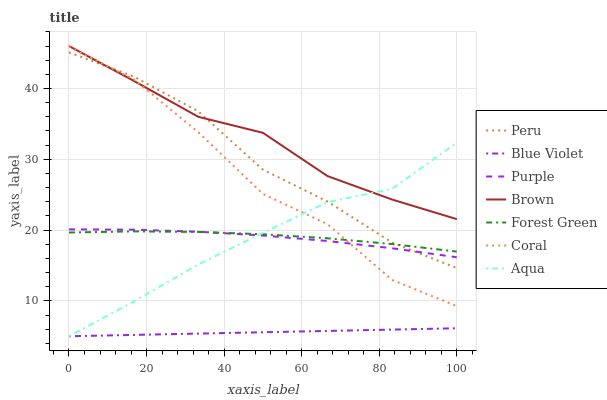Does Blue Violet have the minimum area under the curve?
Answer yes or no. Yes. Does Brown have the maximum area under the curve?
Answer yes or no. Yes. Does Purple have the minimum area under the curve?
Answer yes or no. No. Does Purple have the maximum area under the curve?
Answer yes or no. No. Is Blue Violet the smoothest?
Answer yes or no. Yes. Is Coral the roughest?
Answer yes or no. Yes. Is Purple the smoothest?
Answer yes or no. No. Is Purple the roughest?
Answer yes or no. No. Does Purple have the lowest value?
Answer yes or no. No. Does Brown have the highest value?
Answer yes or no. Yes. Does Purple have the highest value?
Answer yes or no. No. Is Blue Violet less than Coral?
Answer yes or no. Yes. Is Purple greater than Blue Violet?
Answer yes or no. Yes. Does Purple intersect Aqua?
Answer yes or no. Yes. Is Purple less than Aqua?
Answer yes or no. No. Is Purple greater than Aqua?
Answer yes or no. No. Does Blue Violet intersect Coral?
Answer yes or no. No. 